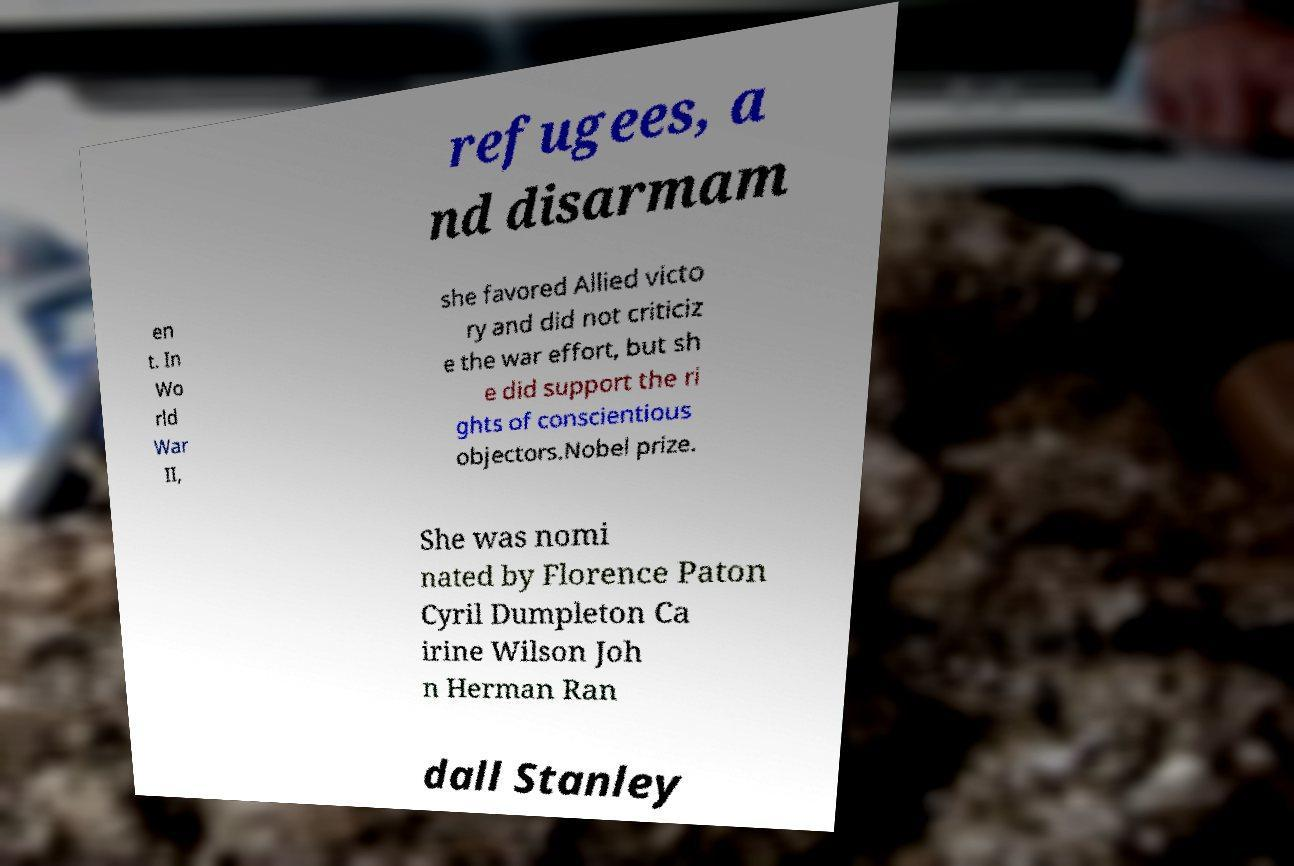Can you accurately transcribe the text from the provided image for me? refugees, a nd disarmam en t. In Wo rld War II, she favored Allied victo ry and did not criticiz e the war effort, but sh e did support the ri ghts of conscientious objectors.Nobel prize. She was nomi nated by Florence Paton Cyril Dumpleton Ca irine Wilson Joh n Herman Ran dall Stanley 